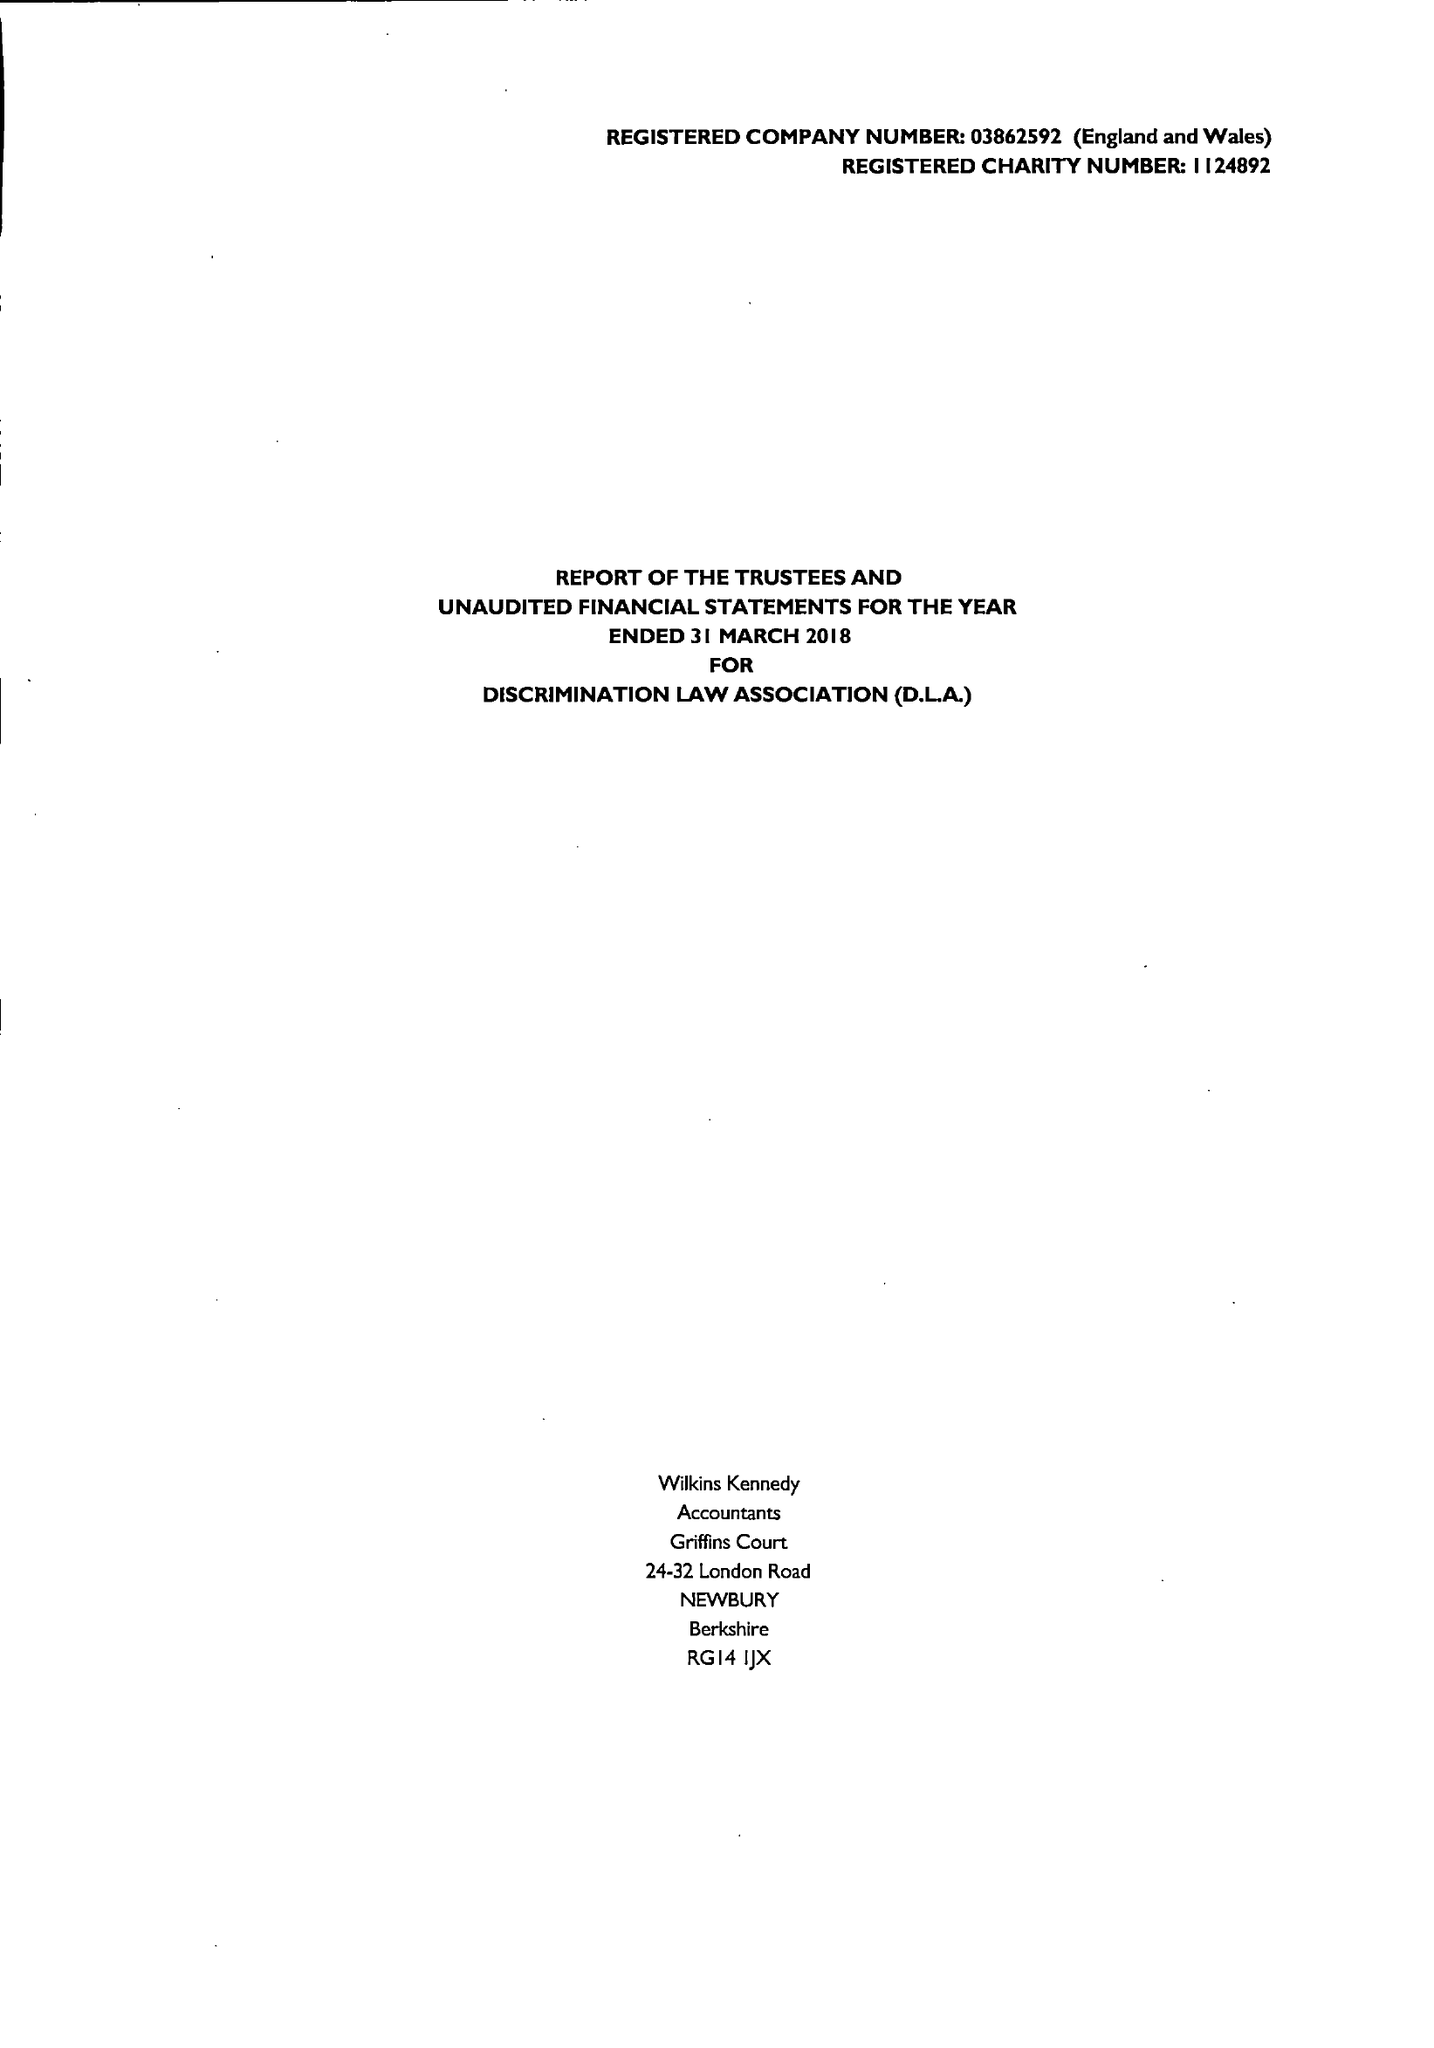What is the value for the address__postcode?
Answer the question using a single word or phrase. N6 5HN 